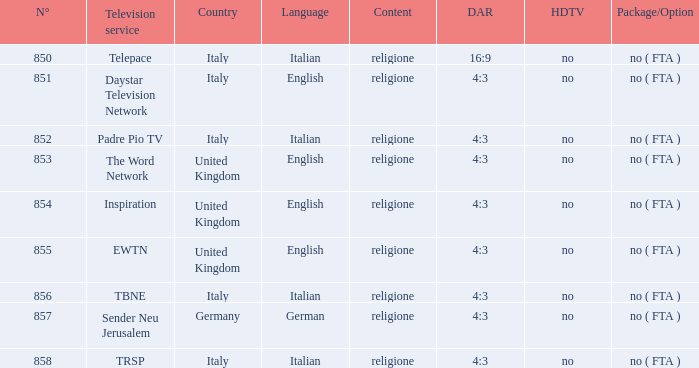How many dar are in germany? 4:3. 